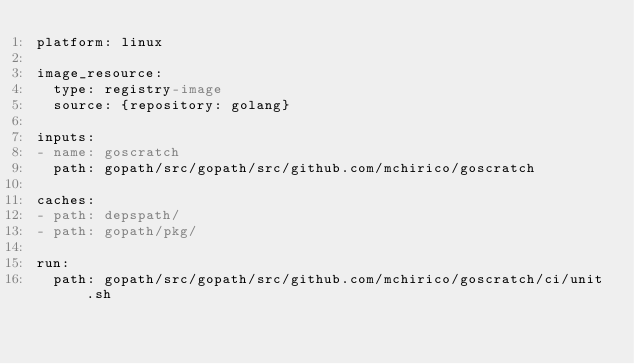Convert code to text. <code><loc_0><loc_0><loc_500><loc_500><_YAML_>platform: linux

image_resource:
  type: registry-image
  source: {repository: golang}

inputs:
- name: goscratch
  path: gopath/src/gopath/src/github.com/mchirico/goscratch

caches:
- path: depspath/
- path: gopath/pkg/

run:
  path: gopath/src/gopath/src/github.com/mchirico/goscratch/ci/unit.sh
</code> 